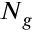Convert formula to latex. <formula><loc_0><loc_0><loc_500><loc_500>N _ { g }</formula> 